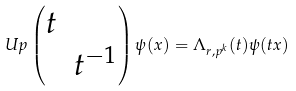Convert formula to latex. <formula><loc_0><loc_0><loc_500><loc_500>\ U p \begin{pmatrix} t & \\ & t ^ { - 1 } \end{pmatrix} \psi ( x ) = \Lambda _ { r , p ^ { k } } ( t ) \psi ( t x )</formula> 